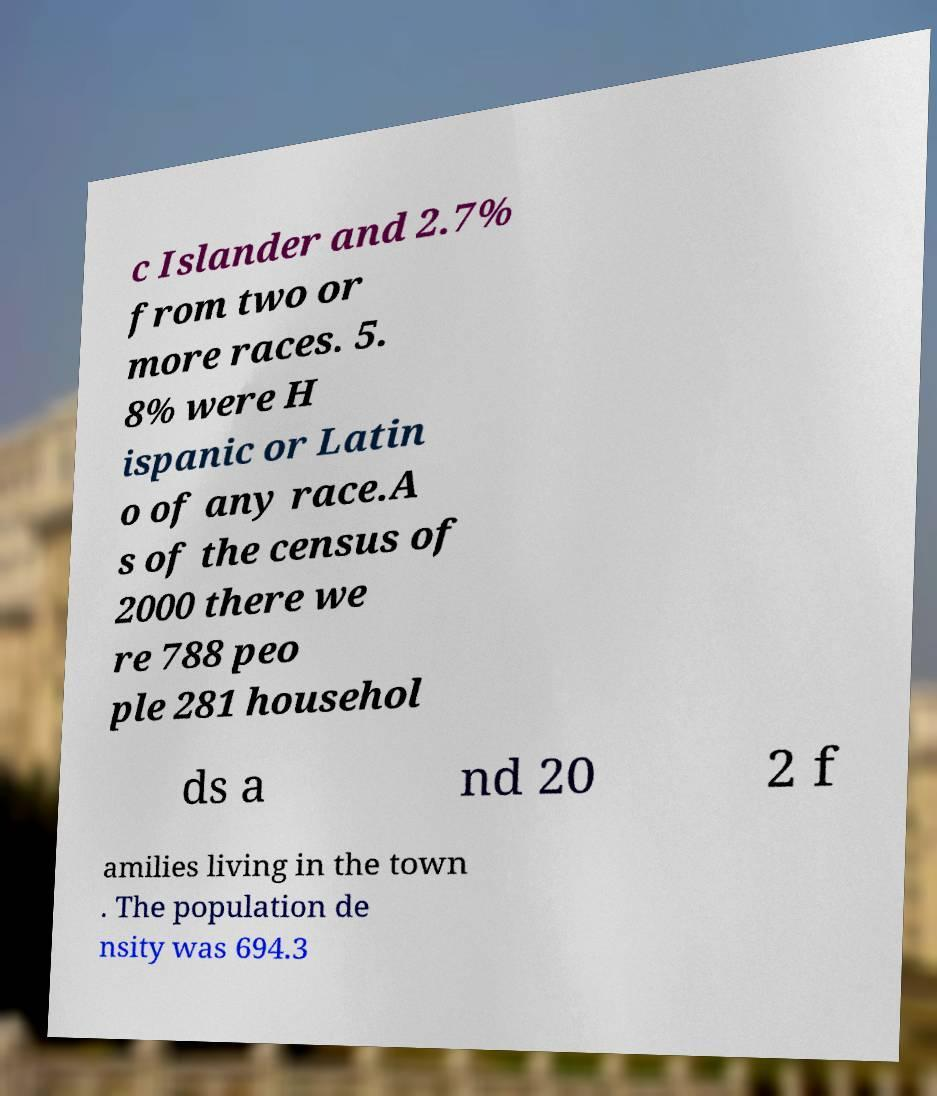For documentation purposes, I need the text within this image transcribed. Could you provide that? c Islander and 2.7% from two or more races. 5. 8% were H ispanic or Latin o of any race.A s of the census of 2000 there we re 788 peo ple 281 househol ds a nd 20 2 f amilies living in the town . The population de nsity was 694.3 